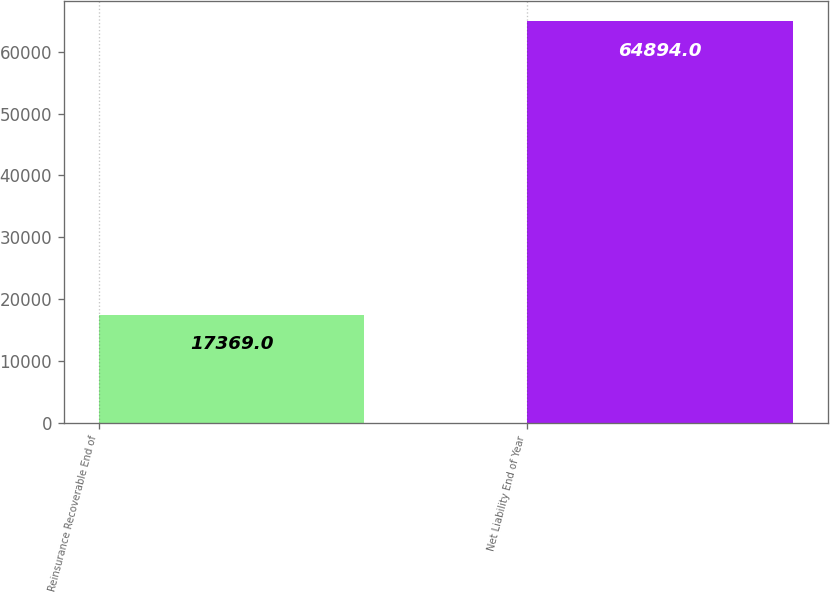Convert chart. <chart><loc_0><loc_0><loc_500><loc_500><bar_chart><fcel>Reinsurance Recoverable End of<fcel>Net Liability End of Year<nl><fcel>17369<fcel>64894<nl></chart> 